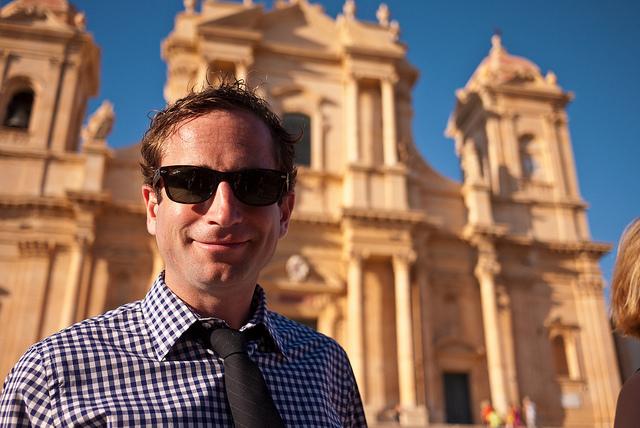What pattern is on the man's shirt?
Short answer required. Plaid. Was this building just built?
Give a very brief answer. No. Is this a man?
Quick response, please. Yes. Is this man wearing sunglasses?
Quick response, please. Yes. 